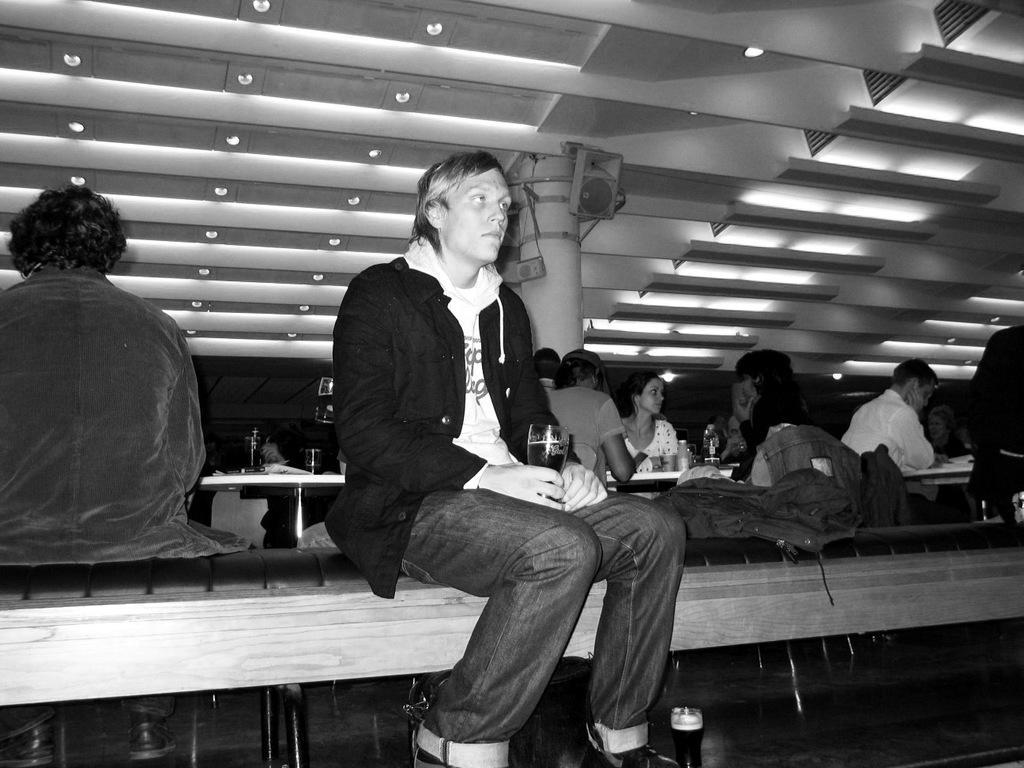In one or two sentences, can you explain what this image depicts? In this picture we can see a man wearing black color coat sitting on the long wooden bench. Behind there is a group of girls sitting on the restaurant table. On the top there is a beautiful ceiling with some lights and music speakers. 